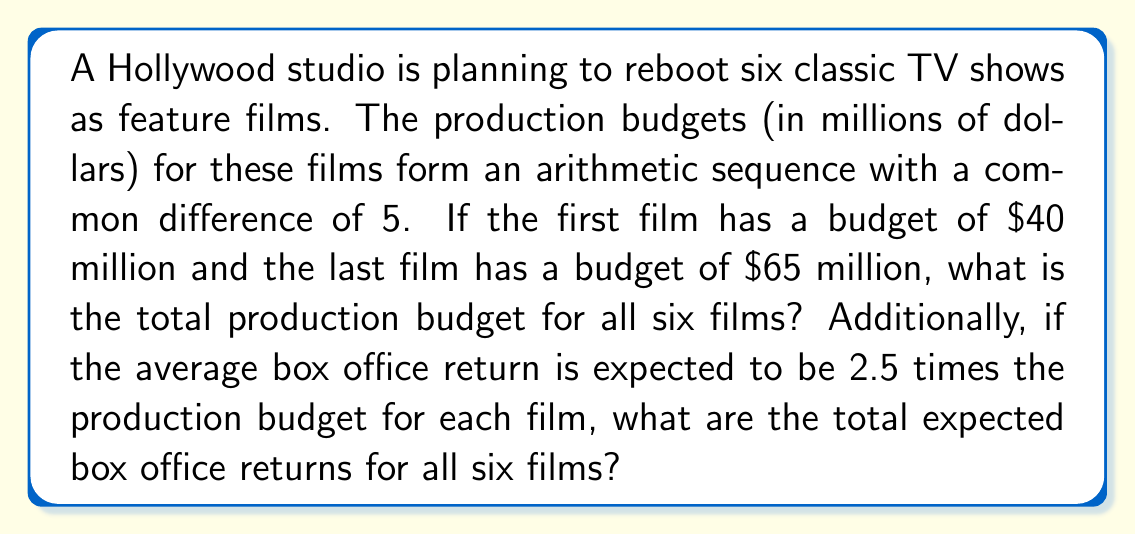Solve this math problem. Let's approach this problem step-by-step:

1) First, let's identify the arithmetic sequence for the production budgets:
   $a_1 = 40$, $a_6 = 65$, and there are 6 terms in total.

2) The common difference $d$ can be calculated:
   $d = \frac{a_6 - a_1}{6-1} = \frac{65 - 40}{5} = 5$

   This confirms the given information that the common difference is 5.

3) The sequence of production budgets is:
   40, 45, 50, 55, 60, 65

4) To find the total production budget, we can use the arithmetic sequence sum formula:
   $$S_n = \frac{n}{2}(a_1 + a_n)$$
   where $n$ is the number of terms, $a_1$ is the first term, and $a_n$ is the last term.

5) Plugging in our values:
   $$S_6 = \frac{6}{2}(40 + 65) = 3(105) = 315$$

6) Therefore, the total production budget is $315 million.

7) For the box office returns, we're told that each film is expected to return 2.5 times its budget.

8) So, the total box office return will be 2.5 times the total budget:
   $$2.5 \times 315 = 787.5$$

Therefore, the total expected box office return is $787.5 million.
Answer: $315 million; $787.5 million 